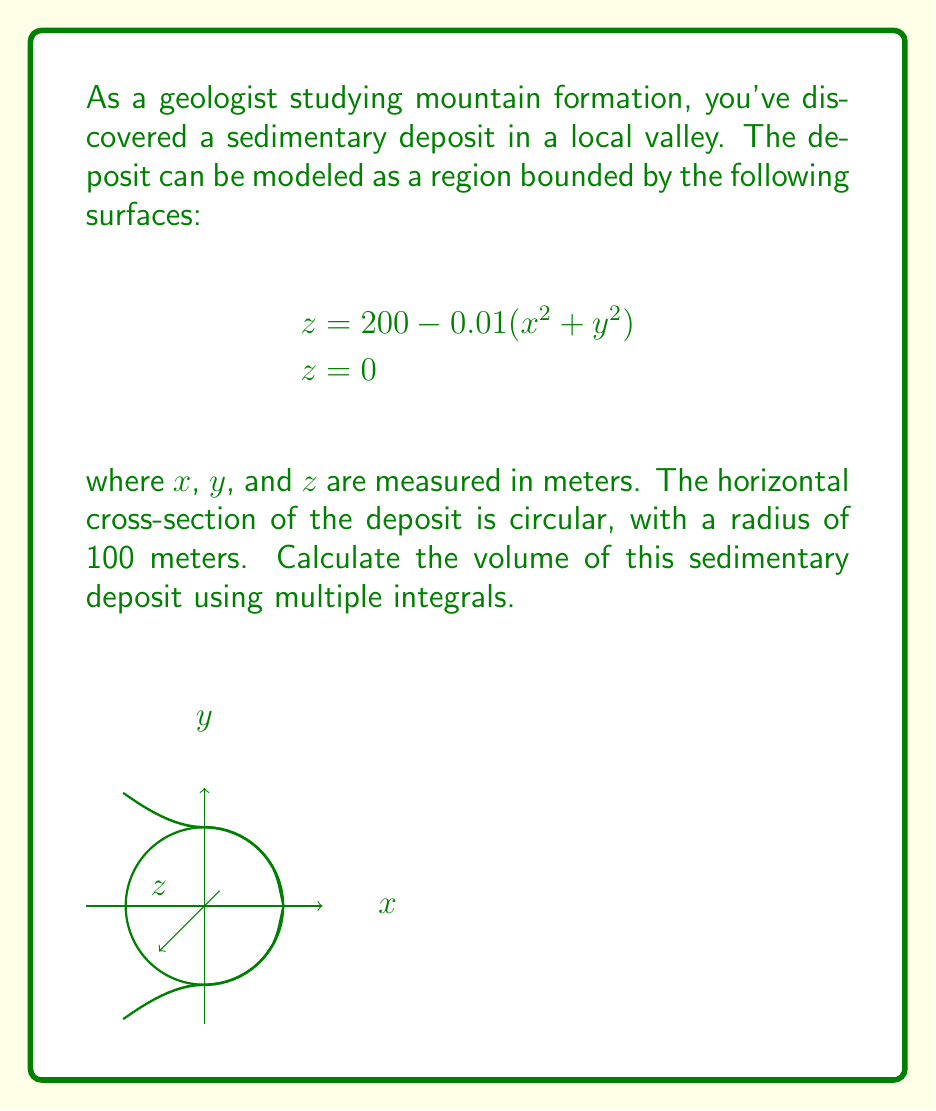Provide a solution to this math problem. To calculate the volume of the sedimentary deposit, we need to set up and evaluate a triple integral. Let's approach this step-by-step:

1) First, we need to determine the limits of integration. Given that the horizontal cross-section is circular with a radius of 100 meters, we can use cylindrical coordinates:

   $0 \leq r \leq 100$
   $0 \leq \theta \leq 2\pi$
   $0 \leq z \leq 200 - 0.01(x^2 + y^2)$

2) In cylindrical coordinates, $x^2 + y^2 = r^2$, so our upper z-limit becomes:

   $z = 200 - 0.01r^2$

3) The volume integral in cylindrical coordinates is:

   $$V = \int_0^{2\pi} \int_0^{100} \int_0^{200-0.01r^2} r \, dz \, dr \, d\theta$$

4) Let's evaluate the inner integral first:

   $$\int_0^{200-0.01r^2} dz = [z]_0^{200-0.01r^2} = 200 - 0.01r^2$$

5) Now our double integral becomes:

   $$V = \int_0^{2\pi} \int_0^{100} r(200 - 0.01r^2) \, dr \, d\theta$$

6) Expand the integrand:

   $$V = \int_0^{2\pi} \int_0^{100} (200r - 0.01r^3) \, dr \, d\theta$$

7) Evaluate the r integral:

   $$V = \int_0^{2\pi} [100r^2 - \frac{0.01}{4}r^4]_0^{100} \, d\theta$$
   $$= \int_0^{2\pi} (1,000,000 - 250,000) \, d\theta$$
   $$= \int_0^{2\pi} 750,000 \, d\theta$$

8) Finally, evaluate the θ integral:

   $$V = [750,000\theta]_0^{2\pi} = 1,500,000\pi$$

Therefore, the volume of the sedimentary deposit is $1,500,000\pi$ cubic meters.
Answer: $1,500,000\pi$ m³ 